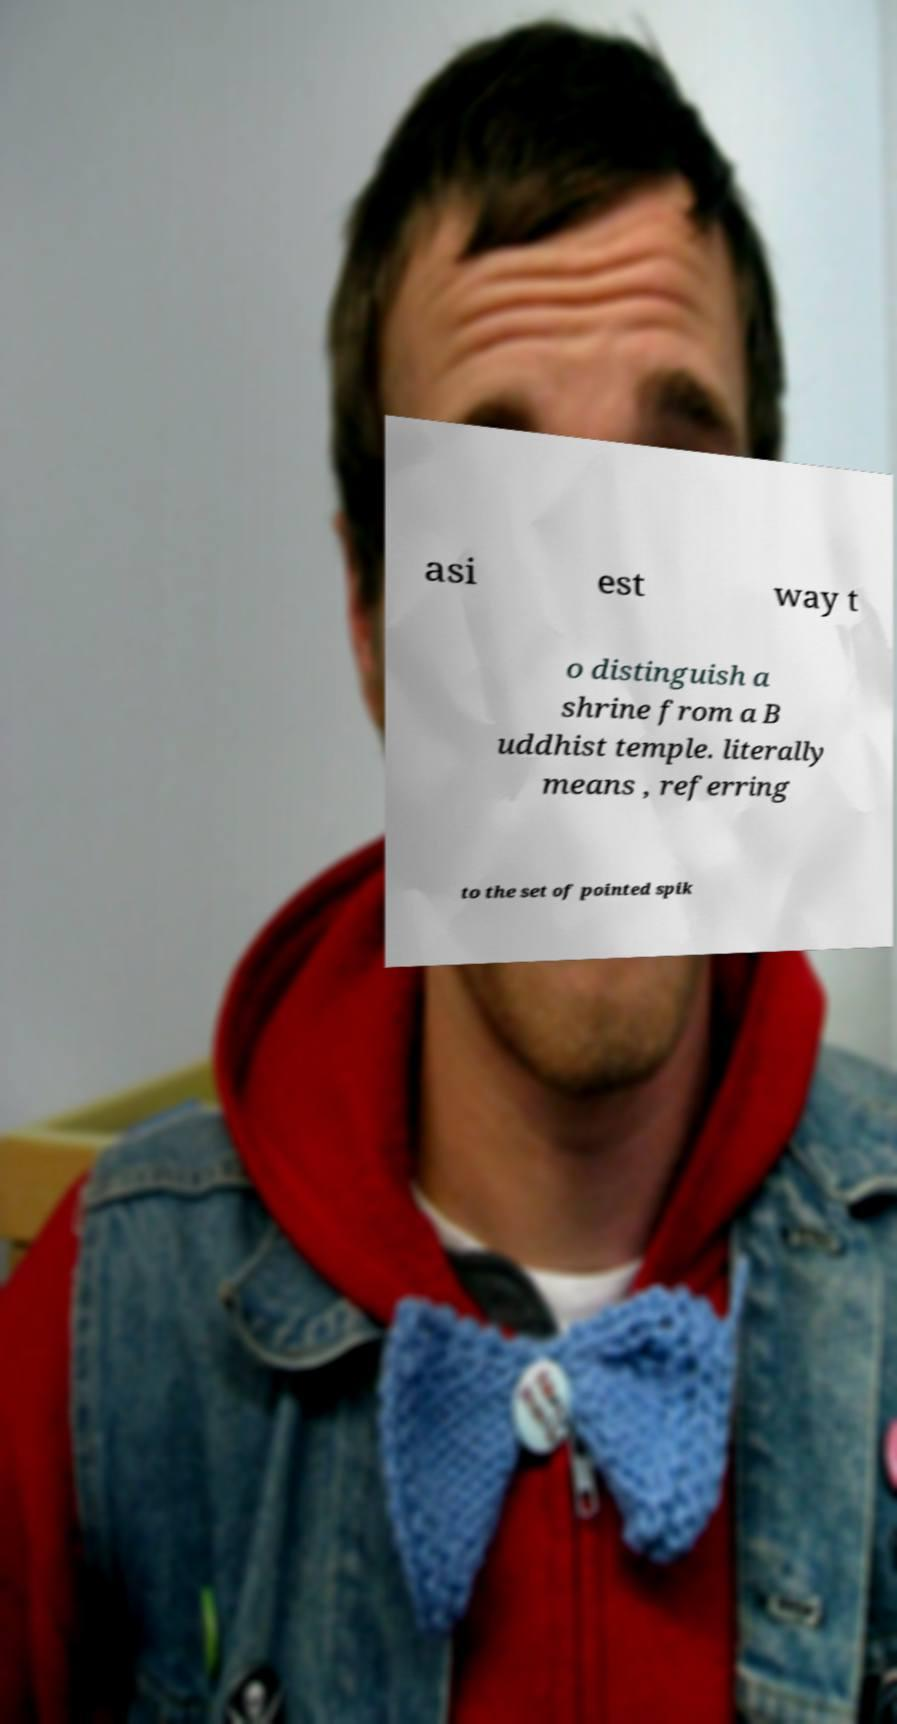Could you extract and type out the text from this image? asi est way t o distinguish a shrine from a B uddhist temple. literally means , referring to the set of pointed spik 